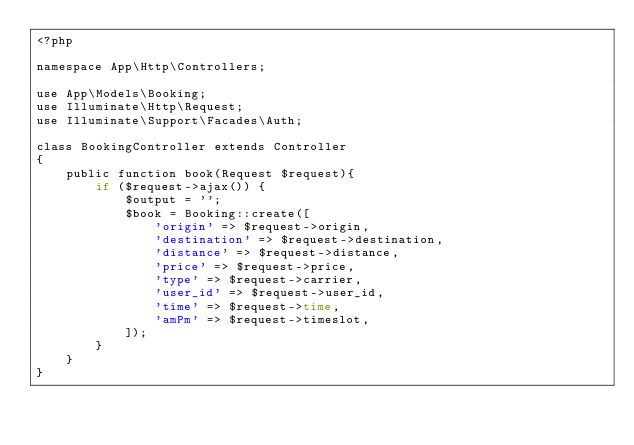Convert code to text. <code><loc_0><loc_0><loc_500><loc_500><_PHP_><?php

namespace App\Http\Controllers;

use App\Models\Booking;
use Illuminate\Http\Request;
use Illuminate\Support\Facades\Auth;

class BookingController extends Controller
{
    public function book(Request $request){
        if ($request->ajax()) {
            $output = '';
            $book = Booking::create([
                'origin' => $request->origin,
                'destination' => $request->destination,
                'distance' => $request->distance,
                'price' => $request->price,
                'type' => $request->carrier,
                'user_id' => $request->user_id,
                'time' => $request->time,
                'amPm' => $request->timeslot,
            ]);
        }
    }
}
</code> 